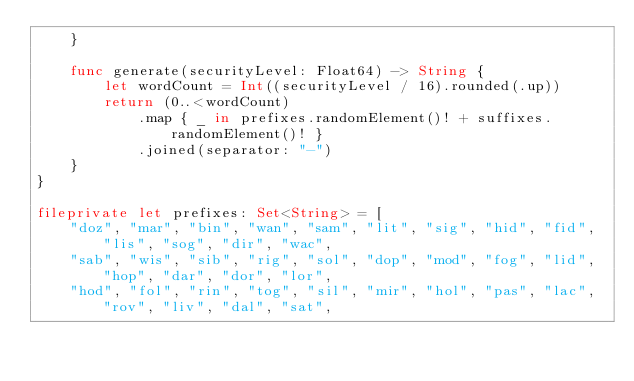<code> <loc_0><loc_0><loc_500><loc_500><_Swift_>    }
    
    func generate(securityLevel: Float64) -> String {
        let wordCount = Int((securityLevel / 16).rounded(.up))
        return (0..<wordCount)
            .map { _ in prefixes.randomElement()! + suffixes.randomElement()! }
            .joined(separator: "-")
    }
}

fileprivate let prefixes: Set<String> = [
    "doz", "mar", "bin", "wan", "sam", "lit", "sig", "hid", "fid", "lis", "sog", "dir", "wac",
    "sab", "wis", "sib", "rig", "sol", "dop", "mod", "fog", "lid", "hop", "dar", "dor", "lor",
    "hod", "fol", "rin", "tog", "sil", "mir", "hol", "pas", "lac", "rov", "liv", "dal", "sat",</code> 